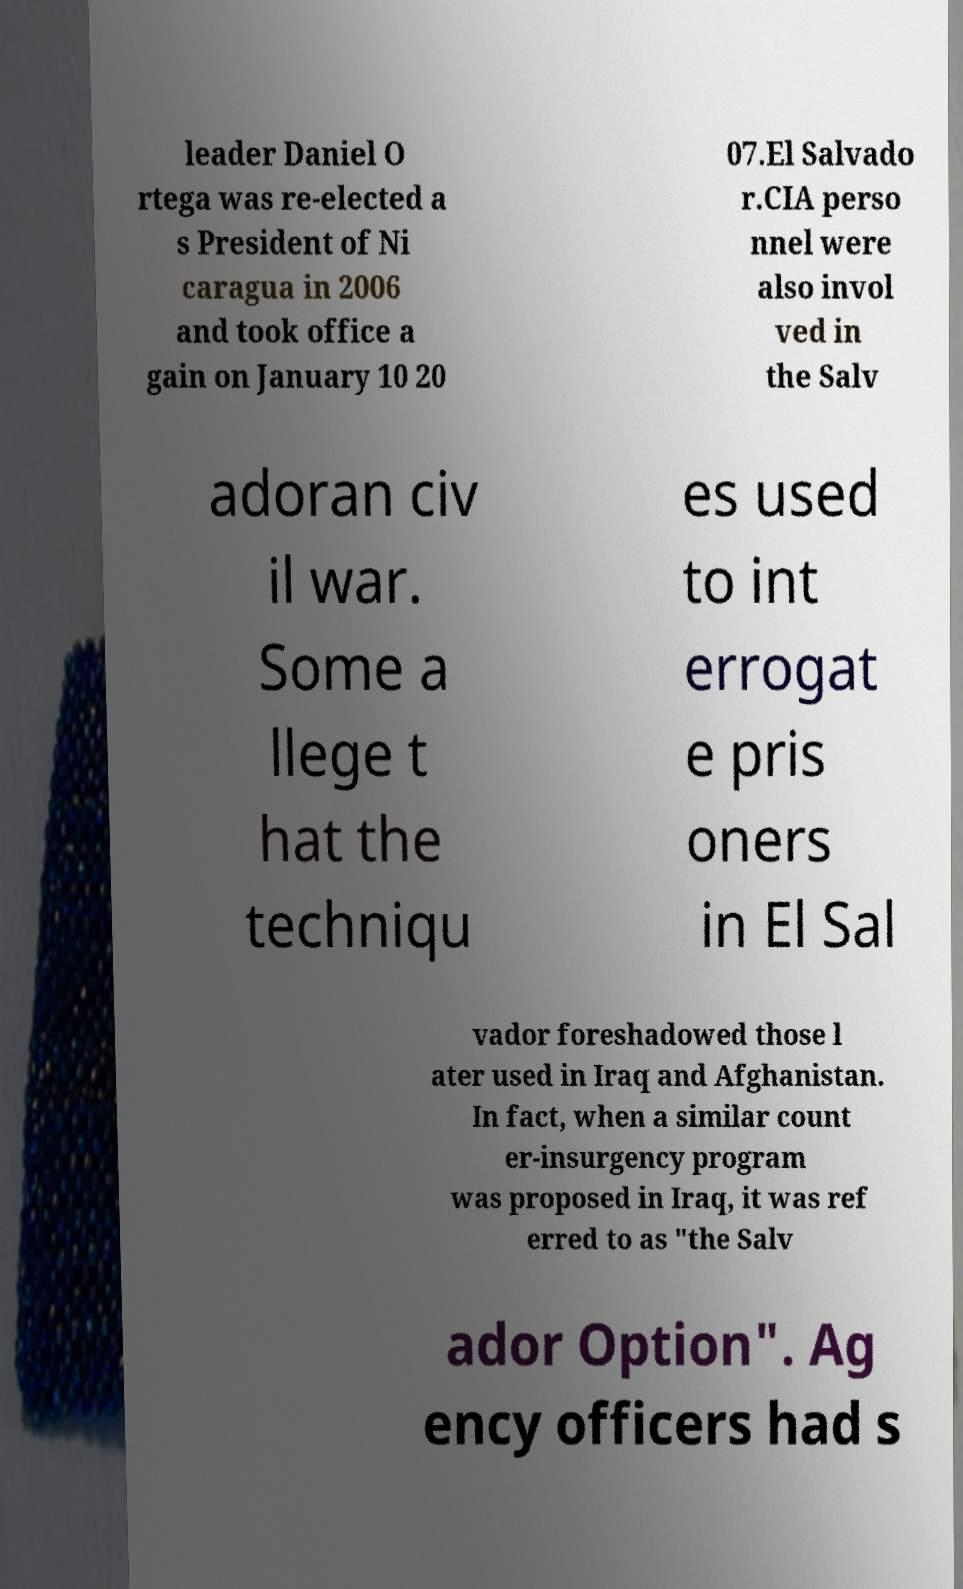I need the written content from this picture converted into text. Can you do that? leader Daniel O rtega was re-elected a s President of Ni caragua in 2006 and took office a gain on January 10 20 07.El Salvado r.CIA perso nnel were also invol ved in the Salv adoran civ il war. Some a llege t hat the techniqu es used to int errogat e pris oners in El Sal vador foreshadowed those l ater used in Iraq and Afghanistan. In fact, when a similar count er-insurgency program was proposed in Iraq, it was ref erred to as "the Salv ador Option". Ag ency officers had s 